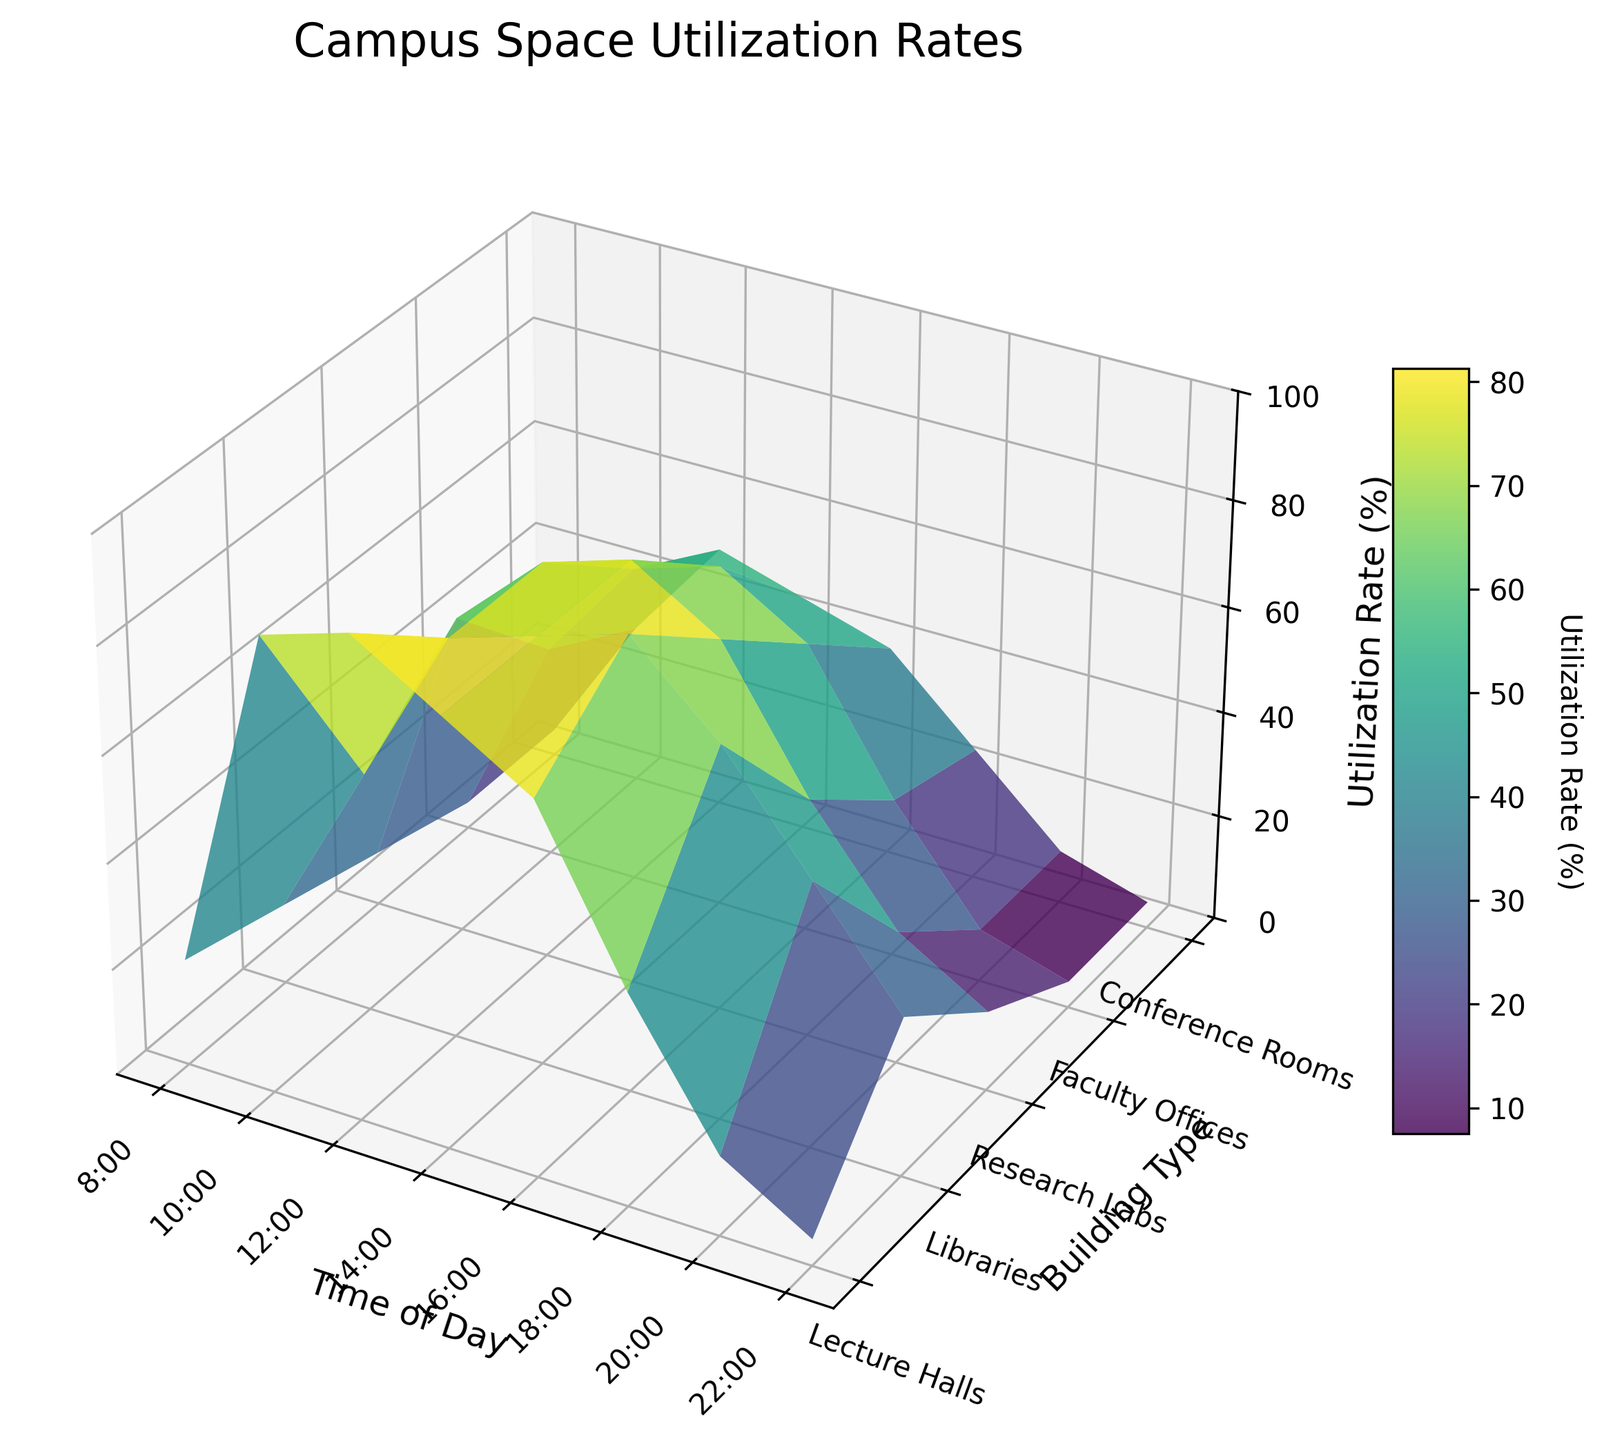What time of day has the highest utilization rate for lecture halls? By observing the 3D surface plot, you can see that the peak utilization rate for lecture halls is when the color is most intensely displayed. The lecture halls have the highest utilization rate at 12:00 PM, where the utilization rate reaches 90%.
Answer: 12:00 PM Which building type sees the greatest variation in utilization rates throughout the day? The greatest variation in utilization rates can be observed by comparing the height difference in the Z-axis across different time points for each building type. The Libraries exhibit a significant range of utilization rates, from 15% at 8:00 AM to 85% at 4:00 PM.
Answer: Libraries What is the utilization rate for faculty offices at 4:00 PM, and how does it compare to the research labs at the same time? At 4:00 PM, the utilization rate for faculty offices can be seen on the Z-axis for the time tick corresponding to 4:00 PM. The faculty offices utilization rate is 55%, while the research labs have a utilization rate of 70%. The research labs have a higher utilization rate at this time.
Answer: Faculty Offices: 55%, Research Labs: 70% What trend can be observed in the lecture halls' utilization rate from 8:00 AM to 10:00 PM? By examining the Z-axis values for Lecture Halls along the time ticks from 8:00 AM to 10:00 PM, there's an initial sharp increase from 8:00 AM (20%) to 10:00 AM (85%). This is followed by fluctuations with a peak at 12:00 PM (90%) and a gradual decline towards 10:00 PM (5%).
Answer: Peaks at 90% at 12:00 PM, then generally declines At what times do conference rooms have a utilization rate of at least 30%? To find this, scan the Y-axis labels for conference rooms and locate the sections on the Z-axis that are 30% or higher. The utilization rates for conference rooms are at least 30% at 10:00 AM, 12:00 PM, 2:00 PM, 4:00 PM, and 6:00 PM.
Answer: 10:00 AM, 12:00 PM, 2:00 PM, 4:00 PM, 6:00 PM How do the utilization rates of research labs and libraries compare at 8:00 PM? The Z-axis values for both research labs and libraries at 8:00 PM show that the research labs have a utilization rate of 25%, while libraries have a utilization rate of 50%. Libraries have a higher utilization rate at 8:00 PM.
Answer: Research Labs: 25%, Libraries: 50% Describe the general utilization trend for the library throughout the day. Observing the 3D surface plot for libraries from 8:00 AM to 10:00 PM, the utilization rate starts at 15%, increases steadily, and peaks at 85% at 4:00 PM before gradually decreasing to 30% by 10:00 PM.
Answer: Increases to a peak at 4:00 PM, then decreases What is the lowest utilization rate for conference rooms throughout the day, and when does it occur? The lowest utilization rate for conference rooms can be seen at the lowest Z-axis values for conference rooms across all time points. It occurs at both 8:00 AM and 10:00 PM, with a utilization rate of 5%.
Answer: 8:00 AM and 10:00 PM, 5% Which time slot has the highest cumulative utilization rate across all building types? Calculate cumulative utilization by summing the Z-axis values for each building type at each time slot. The time slot with the highest cumulative utilization rate is 12:00 PM, where the combined utilization is 350%.
Answer: 12:00 PM How does the utilization rate for research labs at 12:00 PM compare to that at 6:00 PM? Checking the Z-axis values for research labs, the utilization rate at 12:00 PM is 75%, while at 6:00 PM, it drops to 45%. There is a decrease in utilization rate from 12:00 PM to 6:00 PM.
Answer: 75% at 12:00 PM, 45% at 6:00 PM 